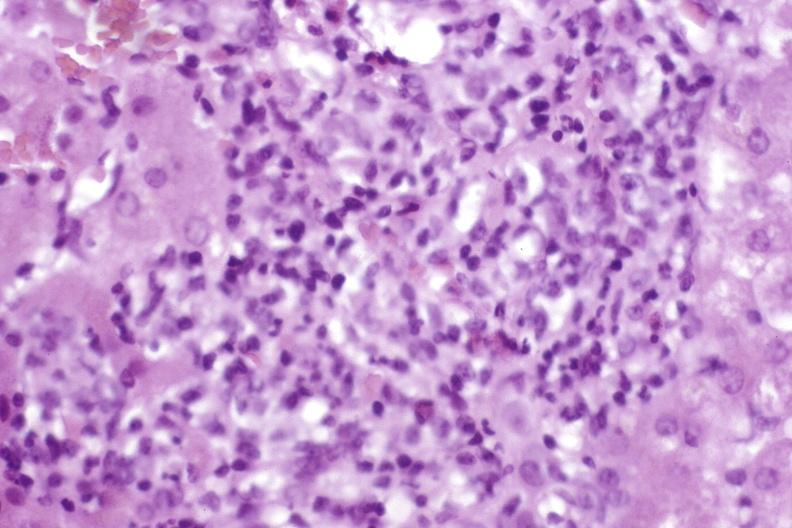s liver present?
Answer the question using a single word or phrase. Yes 